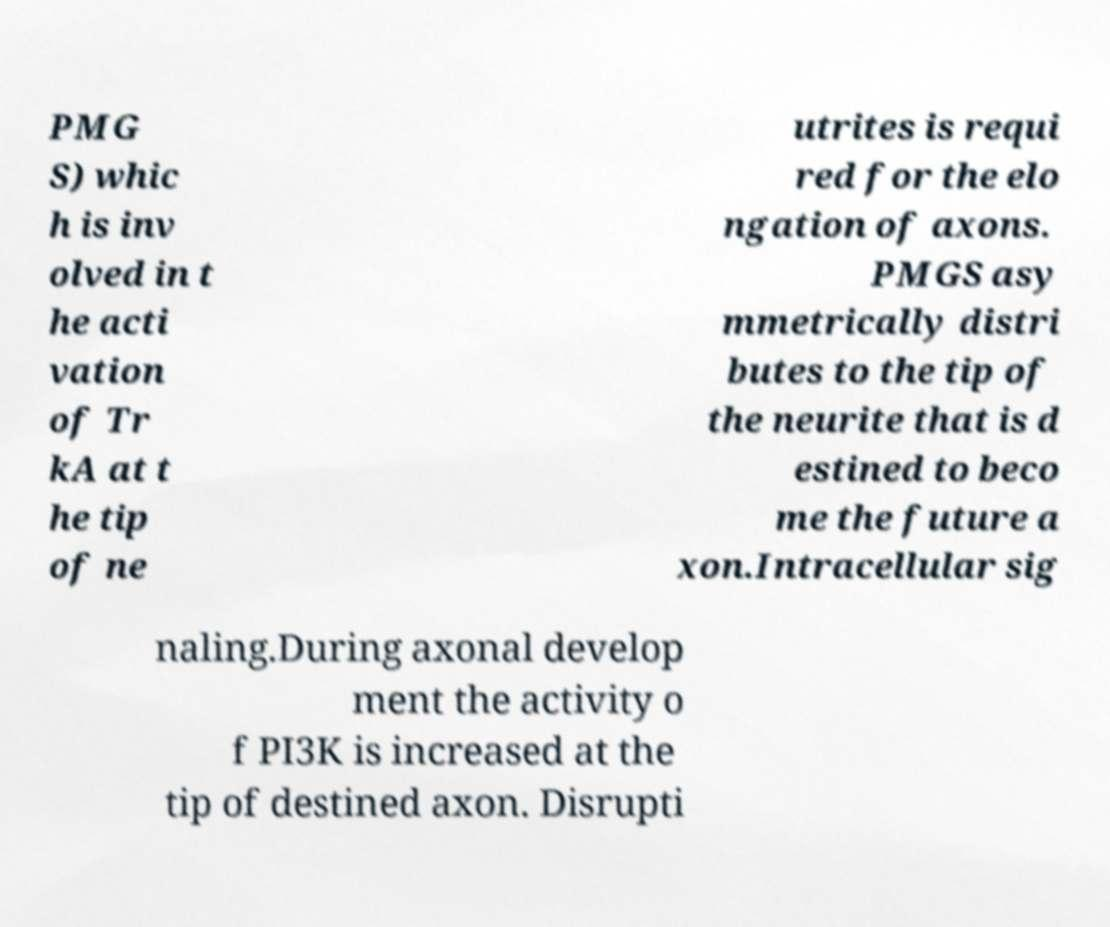Please read and relay the text visible in this image. What does it say? PMG S) whic h is inv olved in t he acti vation of Tr kA at t he tip of ne utrites is requi red for the elo ngation of axons. PMGS asy mmetrically distri butes to the tip of the neurite that is d estined to beco me the future a xon.Intracellular sig naling.During axonal develop ment the activity o f PI3K is increased at the tip of destined axon. Disrupti 